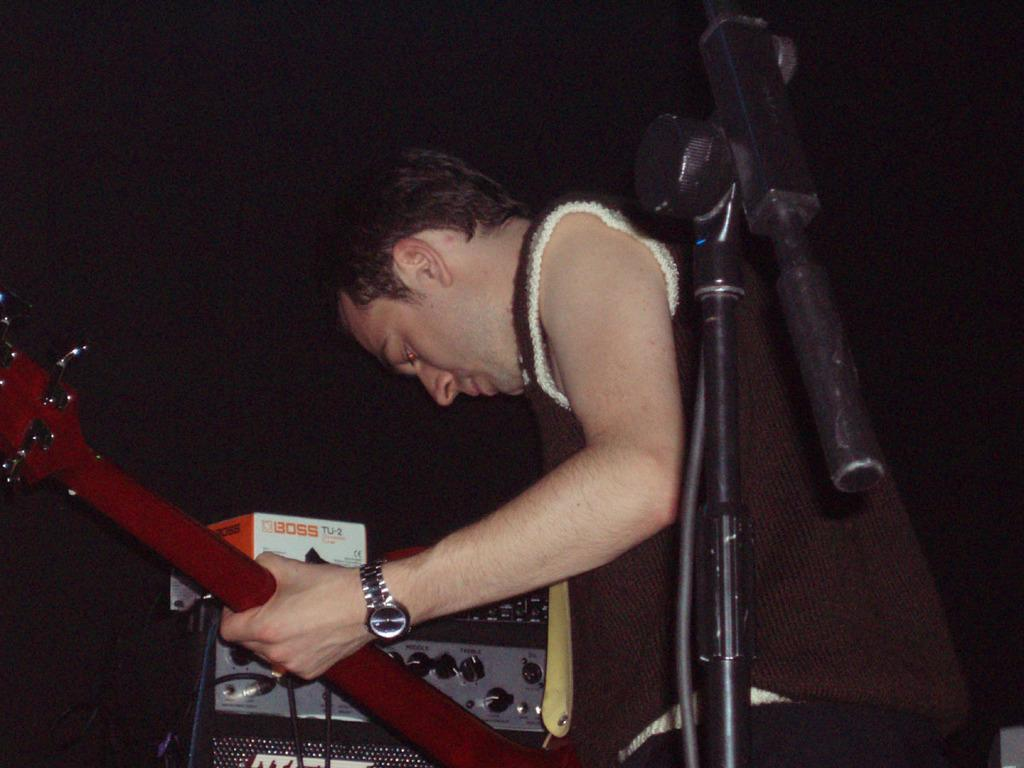What is the man in the image doing? The man is playing a guitar in the image. What object is present that is typically used for amplifying sound? There is a microphone in the image. What type of plate is the man holding in the image? There is no plate present in the image; the man is playing a guitar and there is a microphone nearby. 